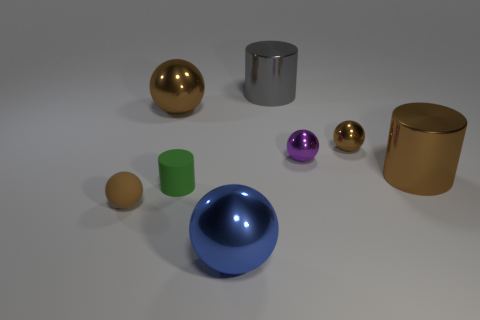Subtract all brown balls. How many were subtracted if there are1brown balls left? 2 Subtract all big brown shiny cylinders. How many cylinders are left? 2 Add 1 big purple blocks. How many objects exist? 9 Subtract all purple balls. How many balls are left? 4 Subtract 2 spheres. How many spheres are left? 3 Subtract all yellow balls. How many purple cylinders are left? 0 Subtract 0 gray cubes. How many objects are left? 8 Subtract all balls. How many objects are left? 3 Subtract all blue cylinders. Subtract all yellow blocks. How many cylinders are left? 3 Subtract all small purple metallic cylinders. Subtract all brown balls. How many objects are left? 5 